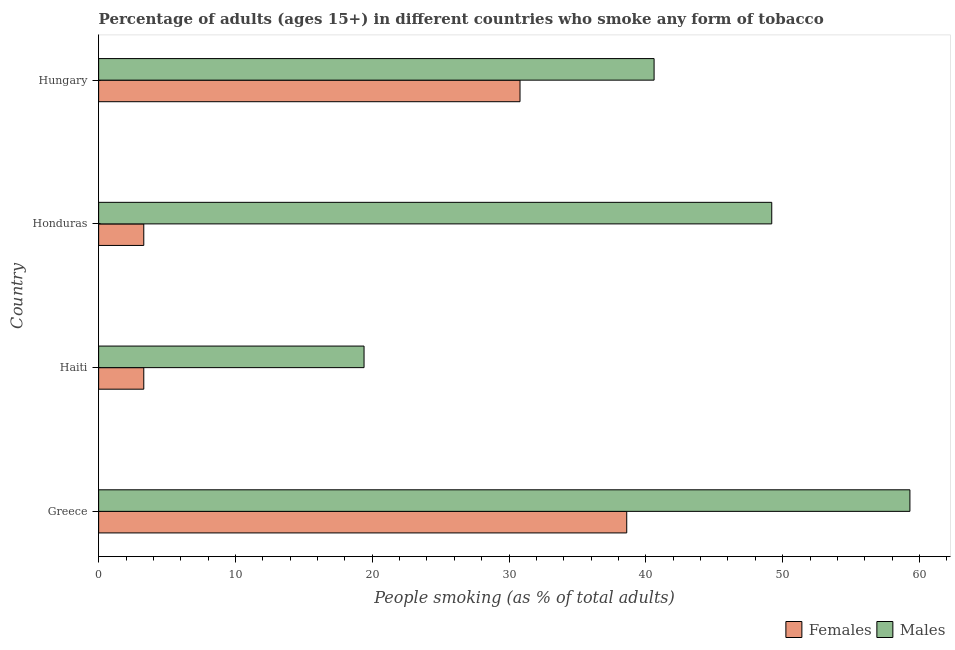How many different coloured bars are there?
Ensure brevity in your answer.  2. Are the number of bars per tick equal to the number of legend labels?
Provide a succinct answer. Yes. What is the label of the 2nd group of bars from the top?
Provide a succinct answer. Honduras. What is the percentage of females who smoke in Greece?
Offer a terse response. 38.6. Across all countries, what is the maximum percentage of females who smoke?
Your answer should be very brief. 38.6. In which country was the percentage of females who smoke minimum?
Give a very brief answer. Haiti. What is the total percentage of males who smoke in the graph?
Your response must be concise. 168.5. What is the difference between the percentage of females who smoke in Greece and that in Honduras?
Your response must be concise. 35.3. What is the difference between the percentage of males who smoke in Honduras and the percentage of females who smoke in Haiti?
Offer a very short reply. 45.9. What is the difference between the percentage of females who smoke and percentage of males who smoke in Honduras?
Make the answer very short. -45.9. What is the ratio of the percentage of females who smoke in Greece to that in Hungary?
Provide a succinct answer. 1.25. Is the difference between the percentage of females who smoke in Greece and Honduras greater than the difference between the percentage of males who smoke in Greece and Honduras?
Ensure brevity in your answer.  Yes. What is the difference between the highest and the second highest percentage of females who smoke?
Provide a short and direct response. 7.8. What is the difference between the highest and the lowest percentage of females who smoke?
Offer a terse response. 35.3. In how many countries, is the percentage of males who smoke greater than the average percentage of males who smoke taken over all countries?
Make the answer very short. 2. What does the 1st bar from the top in Greece represents?
Provide a short and direct response. Males. What does the 2nd bar from the bottom in Greece represents?
Offer a terse response. Males. Are all the bars in the graph horizontal?
Offer a terse response. Yes. How many countries are there in the graph?
Ensure brevity in your answer.  4. Are the values on the major ticks of X-axis written in scientific E-notation?
Your answer should be very brief. No. Does the graph contain grids?
Provide a short and direct response. No. How many legend labels are there?
Make the answer very short. 2. How are the legend labels stacked?
Offer a terse response. Horizontal. What is the title of the graph?
Offer a terse response. Percentage of adults (ages 15+) in different countries who smoke any form of tobacco. Does "Nitrous oxide emissions" appear as one of the legend labels in the graph?
Your answer should be compact. No. What is the label or title of the X-axis?
Make the answer very short. People smoking (as % of total adults). What is the People smoking (as % of total adults) in Females in Greece?
Ensure brevity in your answer.  38.6. What is the People smoking (as % of total adults) of Males in Greece?
Your response must be concise. 59.3. What is the People smoking (as % of total adults) of Females in Haiti?
Provide a succinct answer. 3.3. What is the People smoking (as % of total adults) in Males in Haiti?
Offer a very short reply. 19.4. What is the People smoking (as % of total adults) in Males in Honduras?
Offer a terse response. 49.2. What is the People smoking (as % of total adults) in Females in Hungary?
Provide a short and direct response. 30.8. What is the People smoking (as % of total adults) of Males in Hungary?
Your answer should be compact. 40.6. Across all countries, what is the maximum People smoking (as % of total adults) of Females?
Offer a very short reply. 38.6. Across all countries, what is the maximum People smoking (as % of total adults) of Males?
Make the answer very short. 59.3. Across all countries, what is the minimum People smoking (as % of total adults) in Males?
Give a very brief answer. 19.4. What is the total People smoking (as % of total adults) of Females in the graph?
Provide a short and direct response. 76. What is the total People smoking (as % of total adults) in Males in the graph?
Offer a terse response. 168.5. What is the difference between the People smoking (as % of total adults) of Females in Greece and that in Haiti?
Your answer should be compact. 35.3. What is the difference between the People smoking (as % of total adults) of Males in Greece and that in Haiti?
Offer a terse response. 39.9. What is the difference between the People smoking (as % of total adults) of Females in Greece and that in Honduras?
Offer a very short reply. 35.3. What is the difference between the People smoking (as % of total adults) of Males in Greece and that in Honduras?
Provide a succinct answer. 10.1. What is the difference between the People smoking (as % of total adults) in Females in Greece and that in Hungary?
Your answer should be compact. 7.8. What is the difference between the People smoking (as % of total adults) of Males in Haiti and that in Honduras?
Make the answer very short. -29.8. What is the difference between the People smoking (as % of total adults) in Females in Haiti and that in Hungary?
Your answer should be very brief. -27.5. What is the difference between the People smoking (as % of total adults) of Males in Haiti and that in Hungary?
Offer a terse response. -21.2. What is the difference between the People smoking (as % of total adults) of Females in Honduras and that in Hungary?
Offer a very short reply. -27.5. What is the difference between the People smoking (as % of total adults) of Females in Greece and the People smoking (as % of total adults) of Males in Honduras?
Ensure brevity in your answer.  -10.6. What is the difference between the People smoking (as % of total adults) in Females in Haiti and the People smoking (as % of total adults) in Males in Honduras?
Your answer should be very brief. -45.9. What is the difference between the People smoking (as % of total adults) in Females in Haiti and the People smoking (as % of total adults) in Males in Hungary?
Provide a short and direct response. -37.3. What is the difference between the People smoking (as % of total adults) of Females in Honduras and the People smoking (as % of total adults) of Males in Hungary?
Ensure brevity in your answer.  -37.3. What is the average People smoking (as % of total adults) of Females per country?
Offer a terse response. 19. What is the average People smoking (as % of total adults) of Males per country?
Provide a short and direct response. 42.12. What is the difference between the People smoking (as % of total adults) of Females and People smoking (as % of total adults) of Males in Greece?
Offer a very short reply. -20.7. What is the difference between the People smoking (as % of total adults) in Females and People smoking (as % of total adults) in Males in Haiti?
Your response must be concise. -16.1. What is the difference between the People smoking (as % of total adults) in Females and People smoking (as % of total adults) in Males in Honduras?
Offer a very short reply. -45.9. What is the difference between the People smoking (as % of total adults) in Females and People smoking (as % of total adults) in Males in Hungary?
Give a very brief answer. -9.8. What is the ratio of the People smoking (as % of total adults) of Females in Greece to that in Haiti?
Your answer should be compact. 11.7. What is the ratio of the People smoking (as % of total adults) in Males in Greece to that in Haiti?
Keep it short and to the point. 3.06. What is the ratio of the People smoking (as % of total adults) in Females in Greece to that in Honduras?
Offer a terse response. 11.7. What is the ratio of the People smoking (as % of total adults) in Males in Greece to that in Honduras?
Your answer should be very brief. 1.21. What is the ratio of the People smoking (as % of total adults) of Females in Greece to that in Hungary?
Your answer should be compact. 1.25. What is the ratio of the People smoking (as % of total adults) of Males in Greece to that in Hungary?
Provide a succinct answer. 1.46. What is the ratio of the People smoking (as % of total adults) of Males in Haiti to that in Honduras?
Your answer should be very brief. 0.39. What is the ratio of the People smoking (as % of total adults) in Females in Haiti to that in Hungary?
Offer a very short reply. 0.11. What is the ratio of the People smoking (as % of total adults) in Males in Haiti to that in Hungary?
Make the answer very short. 0.48. What is the ratio of the People smoking (as % of total adults) of Females in Honduras to that in Hungary?
Make the answer very short. 0.11. What is the ratio of the People smoking (as % of total adults) in Males in Honduras to that in Hungary?
Offer a very short reply. 1.21. What is the difference between the highest and the second highest People smoking (as % of total adults) of Females?
Keep it short and to the point. 7.8. What is the difference between the highest and the lowest People smoking (as % of total adults) of Females?
Ensure brevity in your answer.  35.3. What is the difference between the highest and the lowest People smoking (as % of total adults) of Males?
Ensure brevity in your answer.  39.9. 